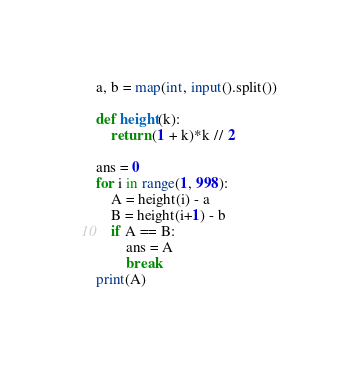Convert code to text. <code><loc_0><loc_0><loc_500><loc_500><_Python_>a, b = map(int, input().split())

def height(k):
    return (1 + k)*k // 2

ans = 0
for i in range(1, 998):
    A = height(i) - a
    B = height(i+1) - b
    if A == B:
        ans = A
        break
print(A)</code> 